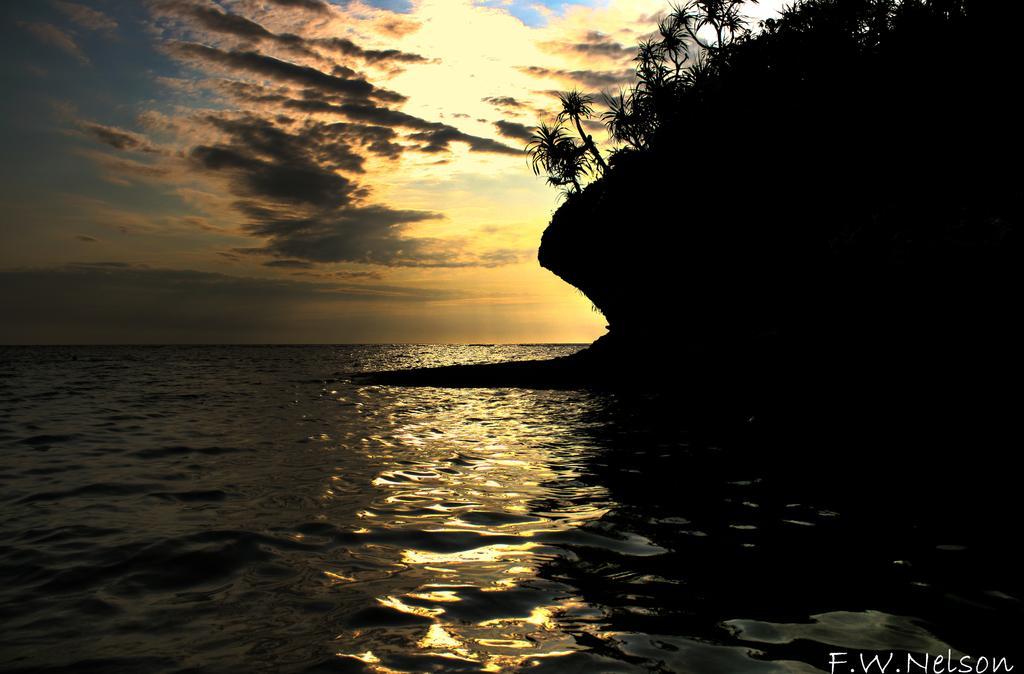In one or two sentences, can you explain what this image depicts? This image is taken outdoors. At the top of the image there is the sky with clouds. At the bottom of the image there is a sea with water. On the right side of the image there is a hill and there are a few trees and plants on the hill. 